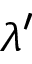Convert formula to latex. <formula><loc_0><loc_0><loc_500><loc_500>\lambda ^ { \prime }</formula> 